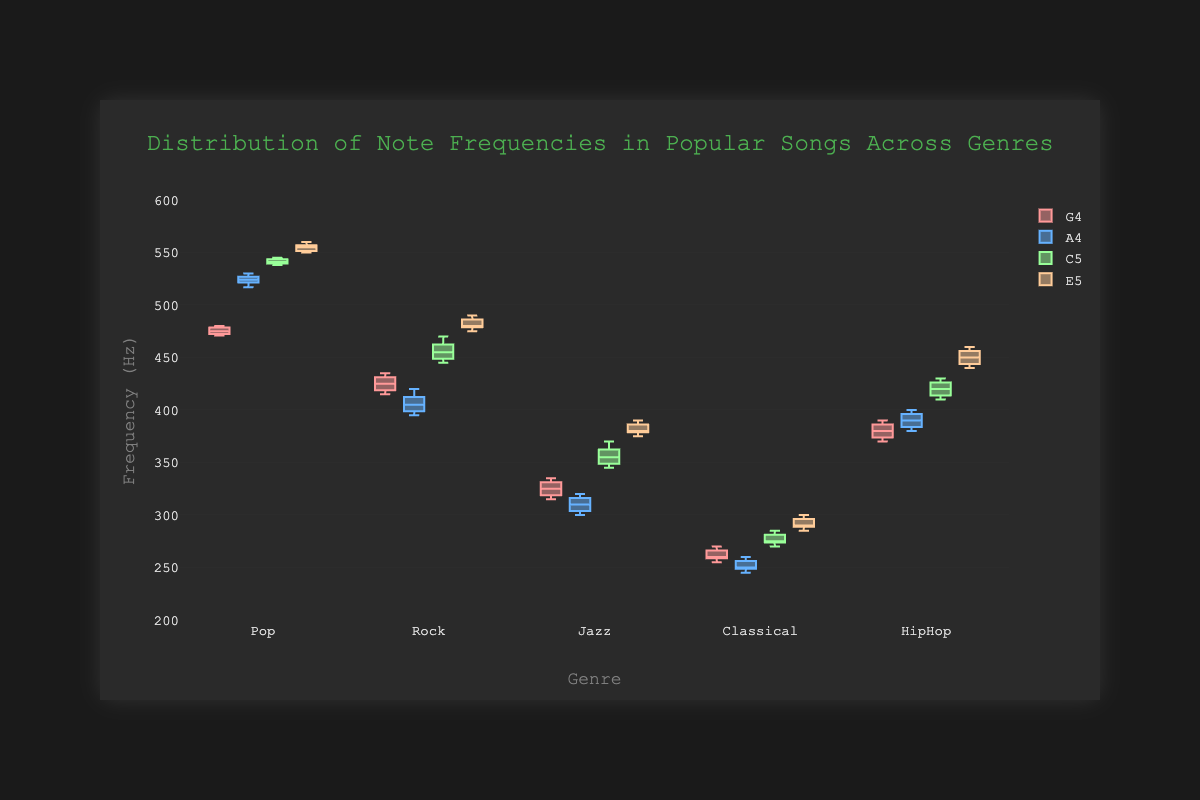What is the title of the chart? The title is usually located at the top of the chart and summarizes what the chart is about. In this case, the title is "Distribution of Note Frequencies in Popular Songs Across Genres".
Answer: Distribution of Note Frequencies in Popular Songs Across Genres Which genre has the highest median frequency for the note A4? Look at the box plot for the note A4 in each genre. The median is the line inside each box. The highest median frequency for A4 is in the Pop genre.
Answer: Pop What is the median frequency of the note C5 in Classical music? Locate the box plot for C5 under Classical music and identify the line inside the box which represents the median. The median value for C5 in Classical music is 275 Hz.
Answer: 275 Hz Which note has the narrowest range of frequencies in Jazz music? The range is the distance between the minimum and maximum values in the box plot. For Jazz, compare the ranges of G4, A4, C5, and E5 by looking at the length of each box plot. The note with the narrowest range is E5.
Answer: E5 Which genre shows the greatest variability in note frequencies for note G4? Variability is represented by the interquartile range (IQR), which is the length of the box in each box plot. Compare the IQR of G4 across all genres. The genre with the greatest variability for G4 is Rock.
Answer: Rock What is the interquartile range (IQR) for the note E5 in HipHop music? The IQR is calculated by subtracting the first quartile (Q1) value from the third quartile (Q3) value in the box plot. For E5 in HipHop, this would typically be the length of the box. The Q3 and Q1 in this range are approximately 455 and 445, thus IQR is 455 - 445 = 10 Hz.
Answer: 10 Hz How do the frequencies of note A4 in Rock compare to those in Pop? To compare, look at the box plots of A4 in Rock and Pop. Notice the median, range, and IQR for each box. The frequencies of A4 in Pop are higher overall and have less variability than in Rock.
Answer: Pop frequencies are higher and less variable Which genre has the lowest maximum frequency for the note G4? The maximum frequency can be observed at the top whisker of the box plot. Compare the top whiskers for G4 across the genres. The genre with the lowest maximum frequency for G4 is Classical.
Answer: Classical What is the median frequency of the note E5 in Jazz music compared to the median frequency of the note E5 in Pop music? Locate the median lines for E5 in both Jazz and Pop music box plots. The median frequency of E5 in Jazz is around 380 Hz, and in Pop, it is around 552 Hz. Therefore, E5 in Pop has a higher median frequency compared to Jazz.
Answer: Pop median is higher Which genre has the smallest range in frequencies overall for the notes shown? To find the genre with the smallest overall range, observe and compare the whiskers' lengths across all notes and genres. Classical music shows generally smaller ranges across the notes G4, A4, C5, and E5.
Answer: Classical 